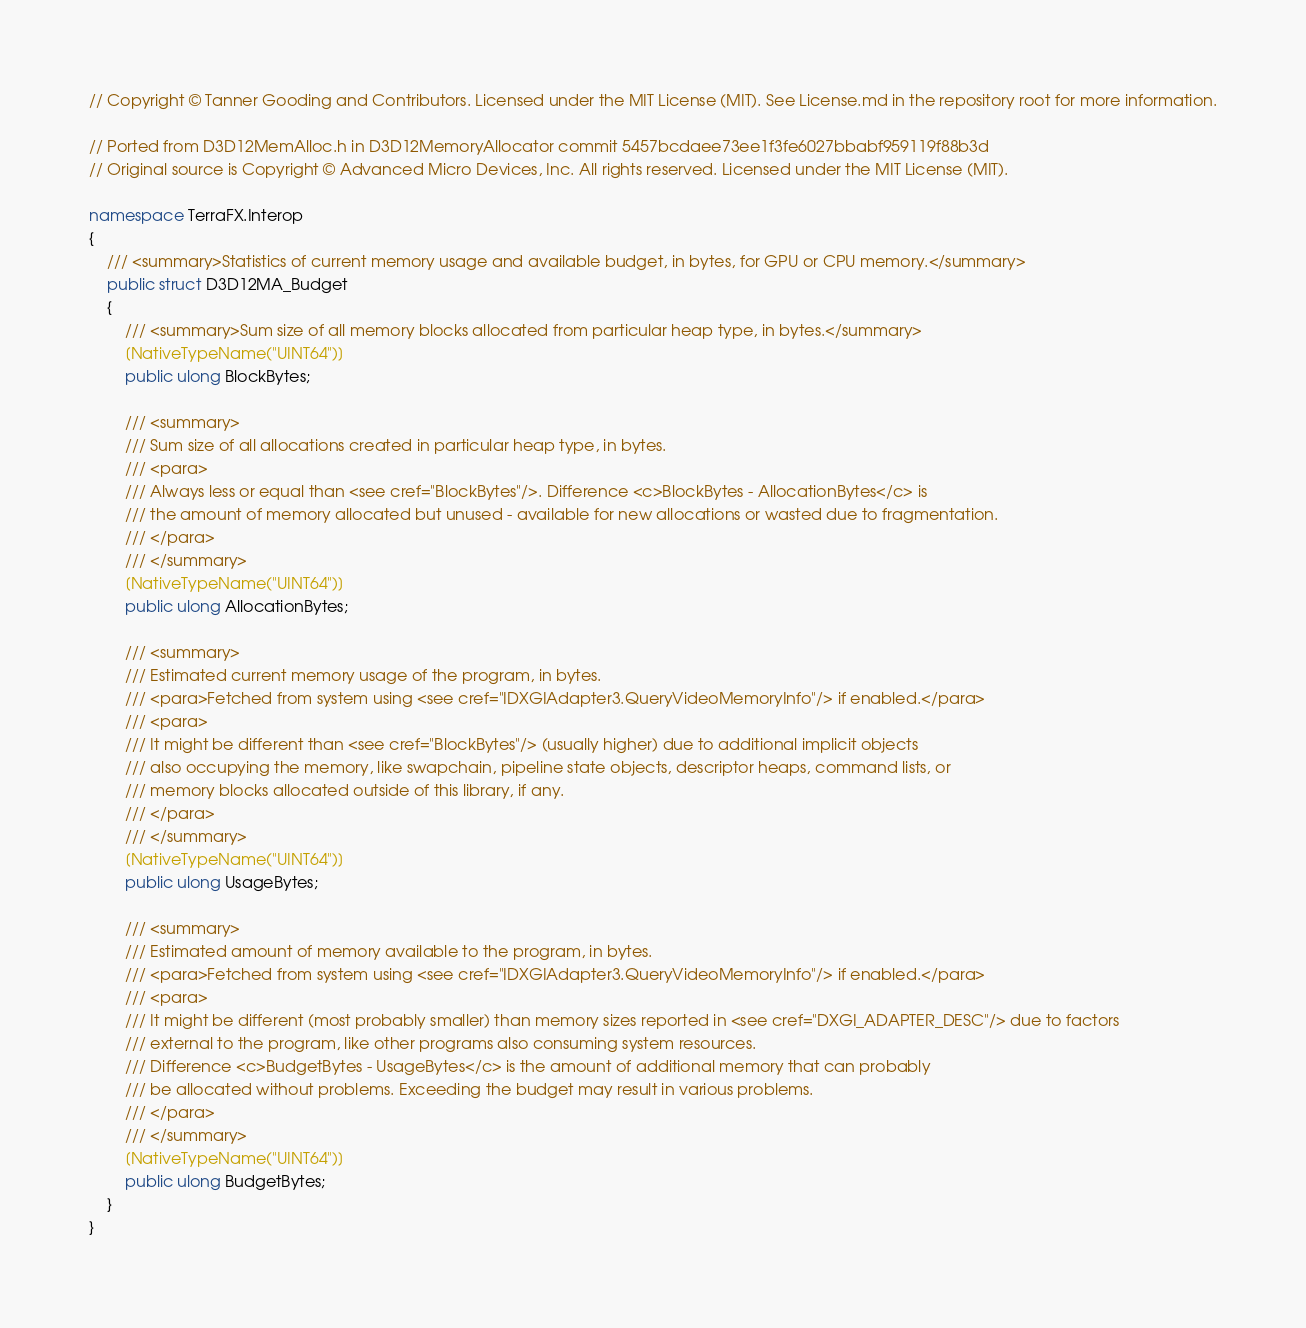Convert code to text. <code><loc_0><loc_0><loc_500><loc_500><_C#_>// Copyright © Tanner Gooding and Contributors. Licensed under the MIT License (MIT). See License.md in the repository root for more information.

// Ported from D3D12MemAlloc.h in D3D12MemoryAllocator commit 5457bcdaee73ee1f3fe6027bbabf959119f88b3d
// Original source is Copyright © Advanced Micro Devices, Inc. All rights reserved. Licensed under the MIT License (MIT).

namespace TerraFX.Interop
{
    /// <summary>Statistics of current memory usage and available budget, in bytes, for GPU or CPU memory.</summary>
    public struct D3D12MA_Budget
    {
        /// <summary>Sum size of all memory blocks allocated from particular heap type, in bytes.</summary>
        [NativeTypeName("UINT64")]
        public ulong BlockBytes;

        /// <summary>
        /// Sum size of all allocations created in particular heap type, in bytes.
        /// <para>
        /// Always less or equal than <see cref="BlockBytes"/>. Difference <c>BlockBytes - AllocationBytes</c> is
        /// the amount of memory allocated but unused - available for new allocations or wasted due to fragmentation.
        /// </para>
        /// </summary>
        [NativeTypeName("UINT64")]
        public ulong AllocationBytes;

        /// <summary>
        /// Estimated current memory usage of the program, in bytes.
        /// <para>Fetched from system using <see cref="IDXGIAdapter3.QueryVideoMemoryInfo"/> if enabled.</para>
        /// <para>
        /// It might be different than <see cref="BlockBytes"/> (usually higher) due to additional implicit objects
        /// also occupying the memory, like swapchain, pipeline state objects, descriptor heaps, command lists, or
        /// memory blocks allocated outside of this library, if any.
        /// </para>
        /// </summary>
        [NativeTypeName("UINT64")]
        public ulong UsageBytes;

        /// <summary>
        /// Estimated amount of memory available to the program, in bytes.
        /// <para>Fetched from system using <see cref="IDXGIAdapter3.QueryVideoMemoryInfo"/> if enabled.</para>
        /// <para>
        /// It might be different (most probably smaller) than memory sizes reported in <see cref="DXGI_ADAPTER_DESC"/> due to factors
        /// external to the program, like other programs also consuming system resources.
        /// Difference <c>BudgetBytes - UsageBytes</c> is the amount of additional memory that can probably
        /// be allocated without problems. Exceeding the budget may result in various problems.
        /// </para>
        /// </summary>
        [NativeTypeName("UINT64")]
        public ulong BudgetBytes;
    }
}
</code> 